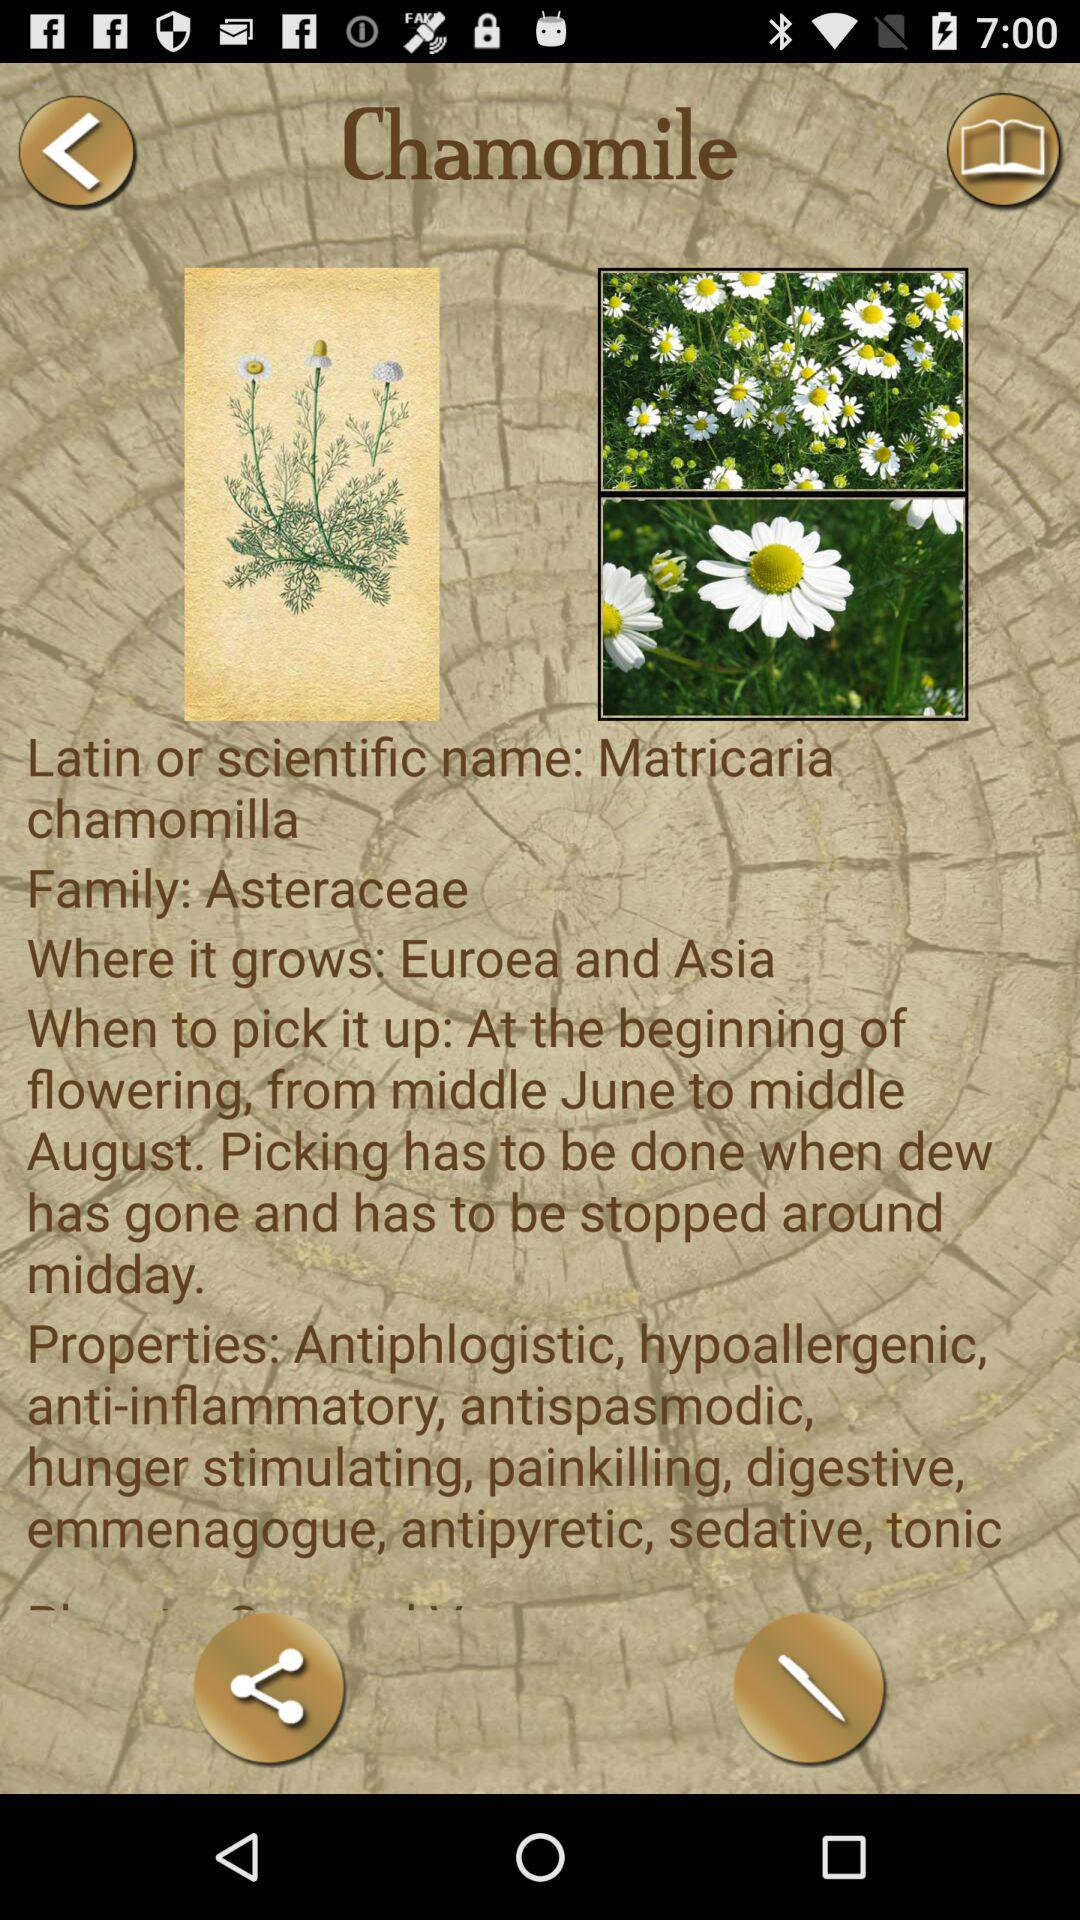What are the properties of a chamomile flower? The properties are antiphlogistic, hypoallergenic, anti-inflammatory, antispasmodic, hunger stimulating, painkilling, digestive, emmenagogue, antipyretic, sedative, tonic. 